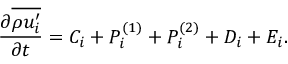Convert formula to latex. <formula><loc_0><loc_0><loc_500><loc_500>\frac { \partial \overline { { \rho u _ { i } ^ { \prime } } } } { \partial t } = C _ { i } + P _ { i } ^ { ( 1 ) } + P _ { i } ^ { ( 2 ) } + D _ { i } + E _ { i } .</formula> 